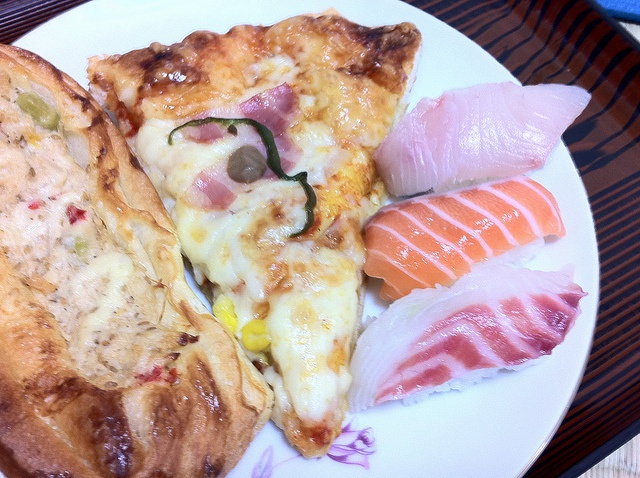Describe the objects in this image and their specific colors. I can see dining table in lavender, tan, and brown tones, pizza in black, lightgray, and tan tones, sandwich in black, tan, lightgray, and brown tones, and pizza in black, tan, lightgray, and brown tones in this image. 